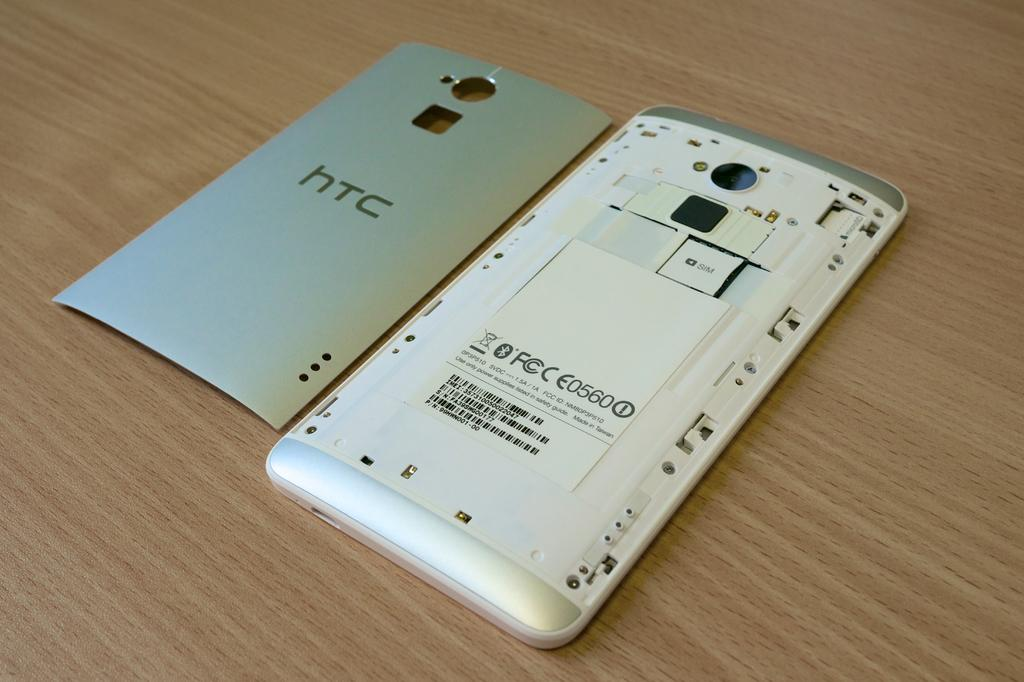<image>
Describe the image concisely. An HTC phone lies on a wooden table with its back removed. 